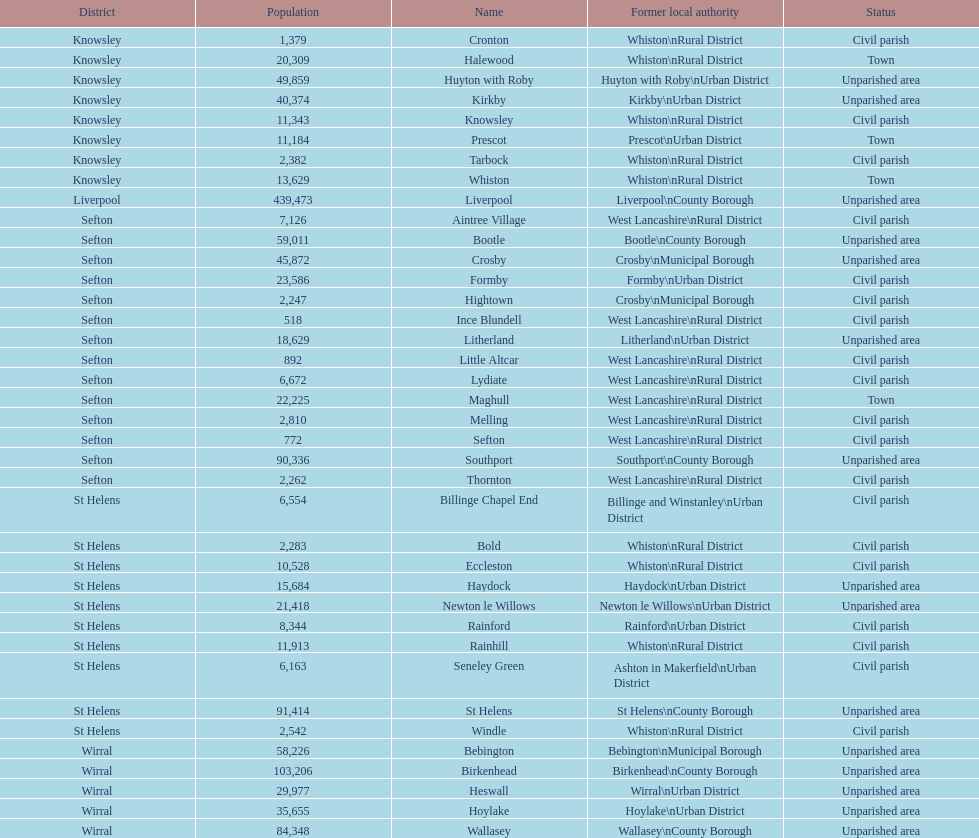Tell me the number of residents in formby. 23,586. 